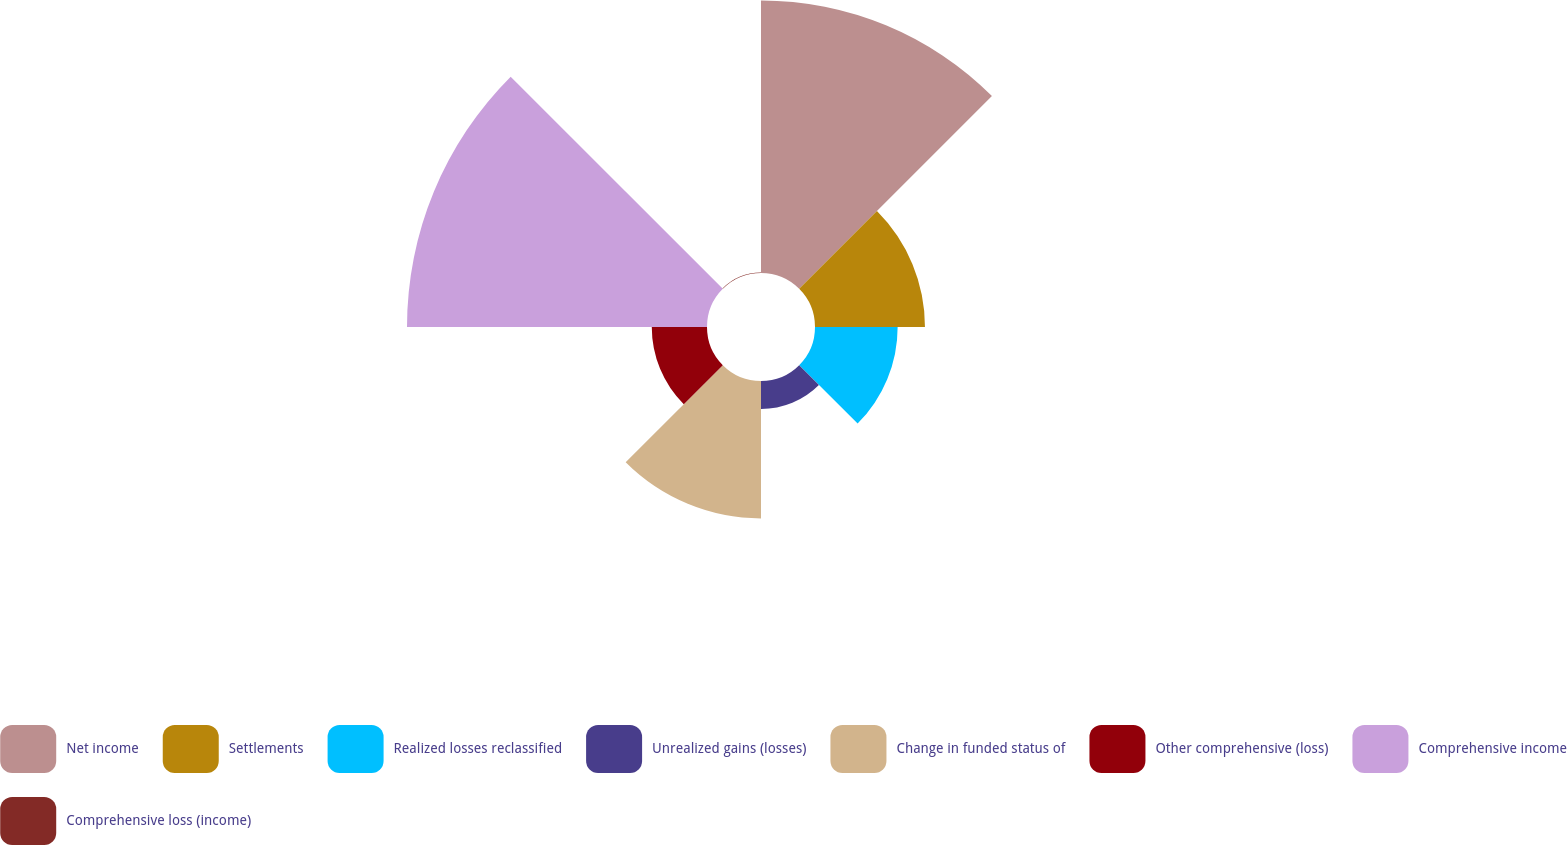Convert chart. <chart><loc_0><loc_0><loc_500><loc_500><pie_chart><fcel>Net income<fcel>Settlements<fcel>Realized losses reclassified<fcel>Unrealized gains (losses)<fcel>Change in funded status of<fcel>Other comprehensive (loss)<fcel>Comprehensive income<fcel>Comprehensive loss (income)<nl><fcel>27.64%<fcel>11.15%<fcel>8.38%<fcel>2.83%<fcel>13.93%<fcel>5.6%<fcel>30.42%<fcel>0.05%<nl></chart> 